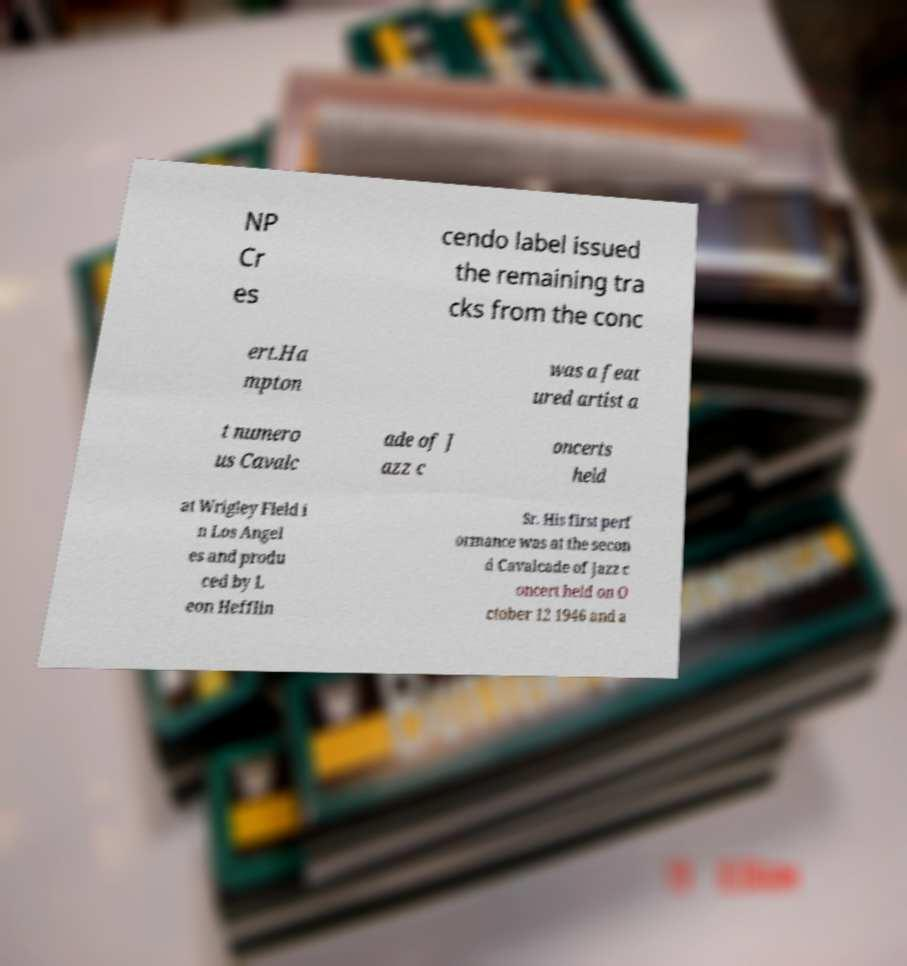Could you assist in decoding the text presented in this image and type it out clearly? NP Cr es cendo label issued the remaining tra cks from the conc ert.Ha mpton was a feat ured artist a t numero us Cavalc ade of J azz c oncerts held at Wrigley Field i n Los Angel es and produ ced by L eon Hefflin Sr. His first perf ormance was at the secon d Cavalcade of Jazz c oncert held on O ctober 12 1946 and a 